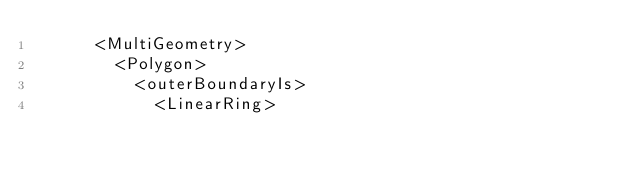<code> <loc_0><loc_0><loc_500><loc_500><_XML_>      <MultiGeometry>
        <Polygon>
          <outerBoundaryIs>
            <LinearRing></code> 